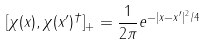<formula> <loc_0><loc_0><loc_500><loc_500>[ \chi ( { x } ) , \chi ( { x ^ { \prime } } ) ^ { \dagger } ] _ { + } = \frac { 1 } { 2 \pi } e ^ { - | { x } - { x ^ { \prime } } | ^ { 2 } / 4 }</formula> 